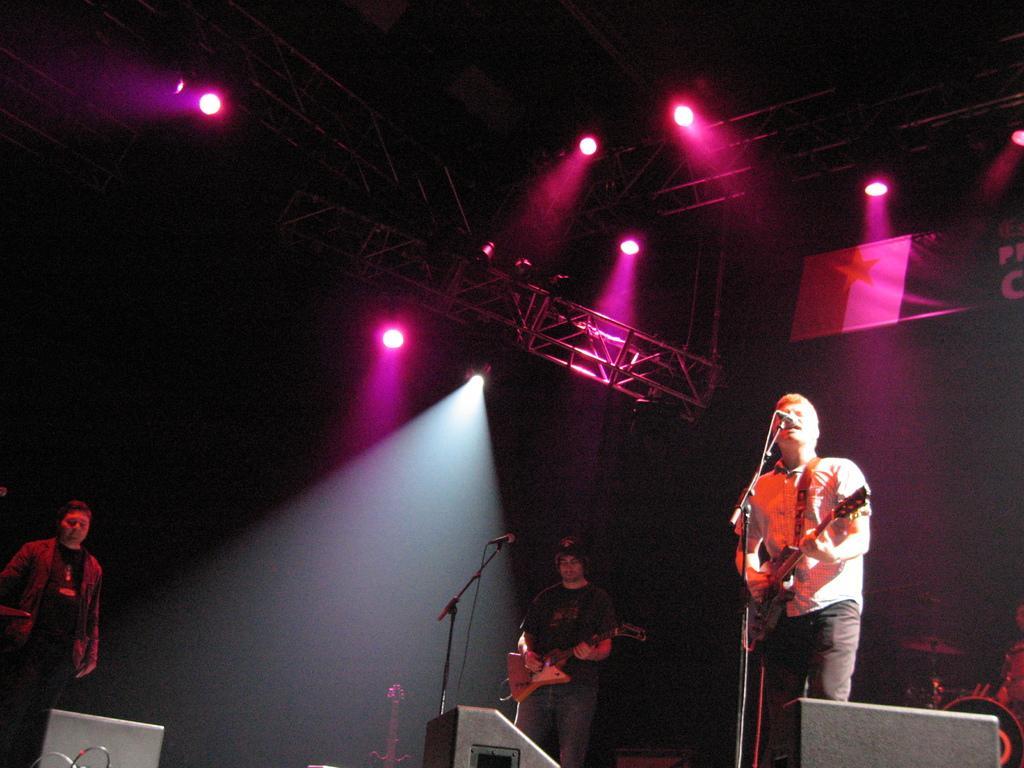Please provide a concise description of this image. In the picture we can see a person holding a guitar near the microphone and just beside to that person we can see another person is holding a guitar near the microphone. And there is a third person standing. In the background we can see a orchestra and a musical instruments and to the ceiling we can see a stand and lights. 